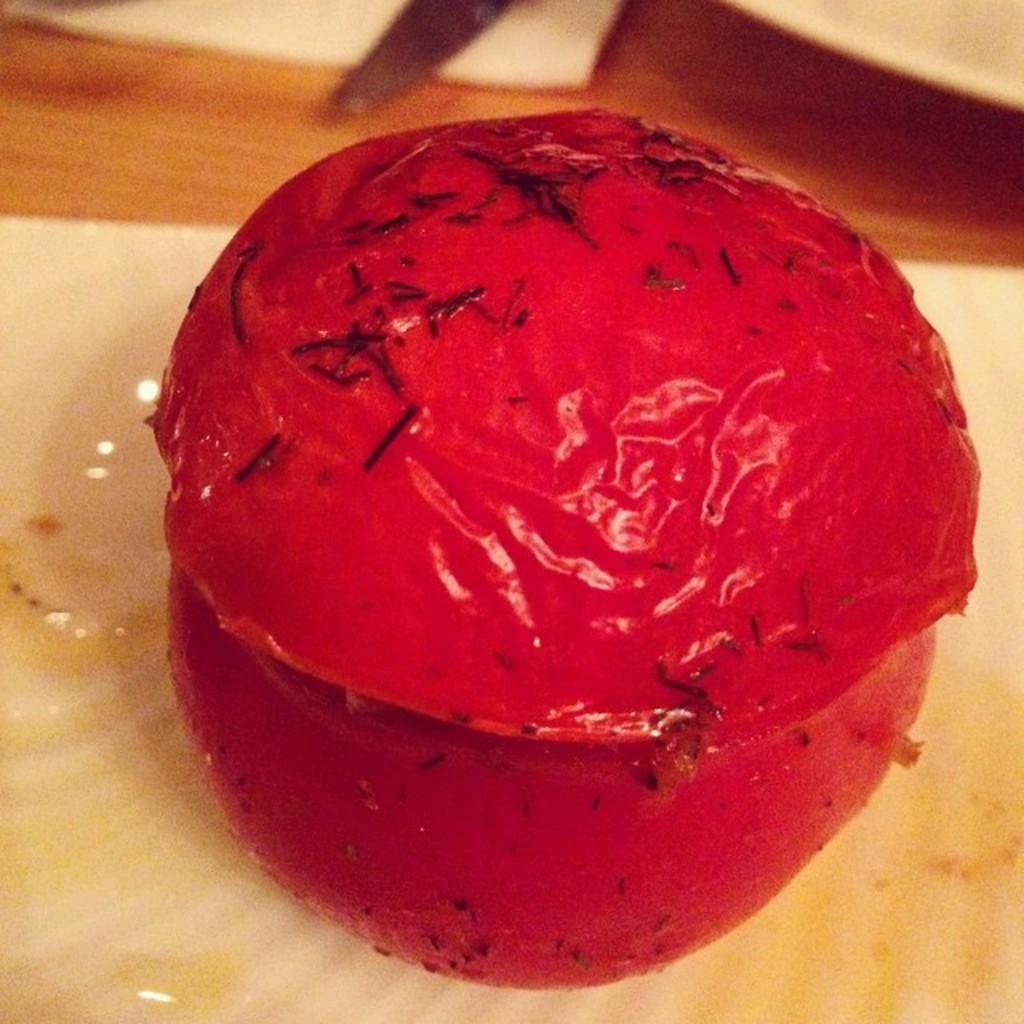Could you give a brief overview of what you see in this image? In this picture we can see a food item on an object. At the top of the image, there are some objects. 